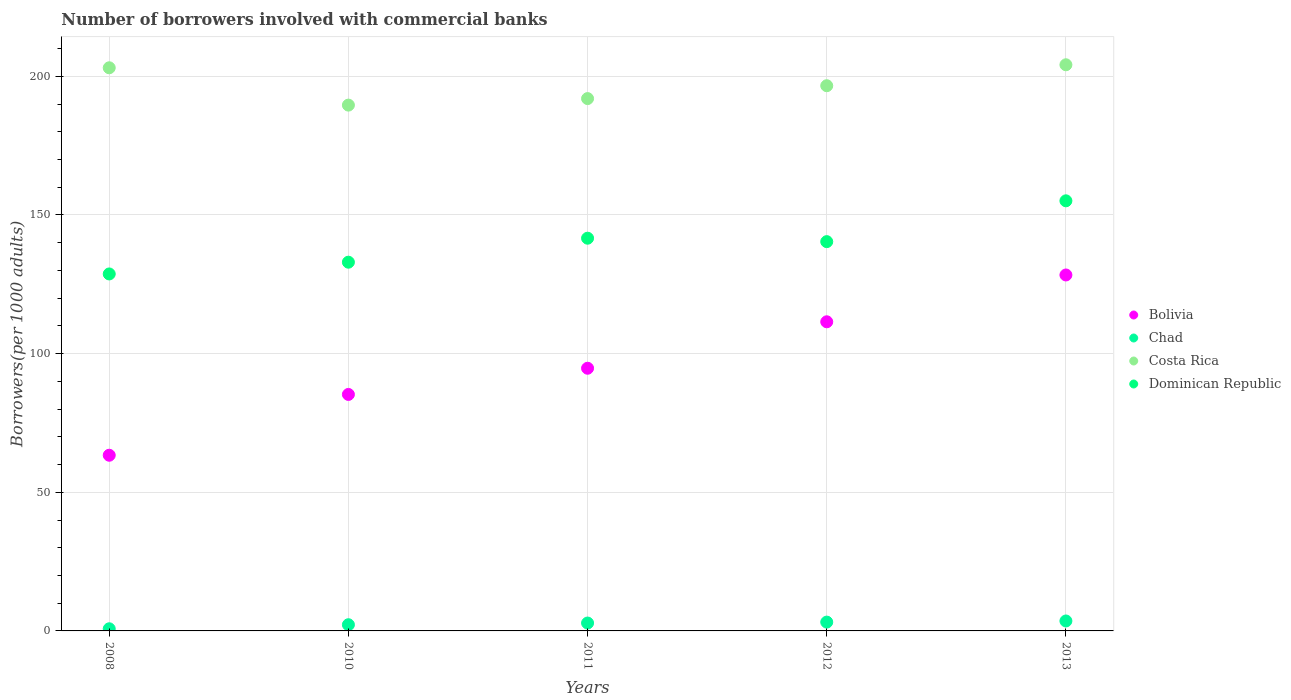How many different coloured dotlines are there?
Give a very brief answer. 4. What is the number of borrowers involved with commercial banks in Bolivia in 2012?
Your answer should be compact. 111.49. Across all years, what is the maximum number of borrowers involved with commercial banks in Chad?
Ensure brevity in your answer.  3.59. Across all years, what is the minimum number of borrowers involved with commercial banks in Costa Rica?
Offer a very short reply. 189.63. In which year was the number of borrowers involved with commercial banks in Bolivia maximum?
Provide a short and direct response. 2013. In which year was the number of borrowers involved with commercial banks in Bolivia minimum?
Your answer should be very brief. 2008. What is the total number of borrowers involved with commercial banks in Chad in the graph?
Provide a short and direct response. 12.62. What is the difference between the number of borrowers involved with commercial banks in Bolivia in 2010 and that in 2012?
Provide a short and direct response. -26.2. What is the difference between the number of borrowers involved with commercial banks in Costa Rica in 2013 and the number of borrowers involved with commercial banks in Chad in 2012?
Keep it short and to the point. 201. What is the average number of borrowers involved with commercial banks in Bolivia per year?
Make the answer very short. 96.65. In the year 2008, what is the difference between the number of borrowers involved with commercial banks in Bolivia and number of borrowers involved with commercial banks in Costa Rica?
Offer a very short reply. -139.73. What is the ratio of the number of borrowers involved with commercial banks in Dominican Republic in 2010 to that in 2011?
Your answer should be very brief. 0.94. Is the difference between the number of borrowers involved with commercial banks in Bolivia in 2008 and 2012 greater than the difference between the number of borrowers involved with commercial banks in Costa Rica in 2008 and 2012?
Provide a succinct answer. No. What is the difference between the highest and the second highest number of borrowers involved with commercial banks in Dominican Republic?
Make the answer very short. 13.49. What is the difference between the highest and the lowest number of borrowers involved with commercial banks in Chad?
Offer a very short reply. 2.82. Is it the case that in every year, the sum of the number of borrowers involved with commercial banks in Costa Rica and number of borrowers involved with commercial banks in Dominican Republic  is greater than the number of borrowers involved with commercial banks in Bolivia?
Provide a succinct answer. Yes. Does the number of borrowers involved with commercial banks in Costa Rica monotonically increase over the years?
Provide a short and direct response. No. Is the number of borrowers involved with commercial banks in Chad strictly less than the number of borrowers involved with commercial banks in Costa Rica over the years?
Provide a short and direct response. Yes. How many years are there in the graph?
Provide a succinct answer. 5. What is the difference between two consecutive major ticks on the Y-axis?
Your answer should be compact. 50. Are the values on the major ticks of Y-axis written in scientific E-notation?
Your response must be concise. No. Where does the legend appear in the graph?
Your response must be concise. Center right. How are the legend labels stacked?
Your answer should be compact. Vertical. What is the title of the graph?
Your answer should be compact. Number of borrowers involved with commercial banks. Does "Gabon" appear as one of the legend labels in the graph?
Ensure brevity in your answer.  No. What is the label or title of the X-axis?
Ensure brevity in your answer.  Years. What is the label or title of the Y-axis?
Offer a very short reply. Borrowers(per 1000 adults). What is the Borrowers(per 1000 adults) of Bolivia in 2008?
Provide a succinct answer. 63.36. What is the Borrowers(per 1000 adults) of Chad in 2008?
Your answer should be very brief. 0.77. What is the Borrowers(per 1000 adults) of Costa Rica in 2008?
Provide a short and direct response. 203.09. What is the Borrowers(per 1000 adults) in Dominican Republic in 2008?
Keep it short and to the point. 128.74. What is the Borrowers(per 1000 adults) in Bolivia in 2010?
Keep it short and to the point. 85.29. What is the Borrowers(per 1000 adults) of Chad in 2010?
Make the answer very short. 2.24. What is the Borrowers(per 1000 adults) of Costa Rica in 2010?
Your response must be concise. 189.63. What is the Borrowers(per 1000 adults) in Dominican Republic in 2010?
Your answer should be compact. 132.98. What is the Borrowers(per 1000 adults) of Bolivia in 2011?
Your response must be concise. 94.73. What is the Borrowers(per 1000 adults) of Chad in 2011?
Your answer should be compact. 2.84. What is the Borrowers(per 1000 adults) in Costa Rica in 2011?
Your answer should be very brief. 191.98. What is the Borrowers(per 1000 adults) in Dominican Republic in 2011?
Keep it short and to the point. 141.63. What is the Borrowers(per 1000 adults) of Bolivia in 2012?
Make the answer very short. 111.49. What is the Borrowers(per 1000 adults) of Chad in 2012?
Keep it short and to the point. 3.18. What is the Borrowers(per 1000 adults) in Costa Rica in 2012?
Ensure brevity in your answer.  196.62. What is the Borrowers(per 1000 adults) in Dominican Republic in 2012?
Provide a short and direct response. 140.39. What is the Borrowers(per 1000 adults) of Bolivia in 2013?
Your answer should be compact. 128.37. What is the Borrowers(per 1000 adults) in Chad in 2013?
Give a very brief answer. 3.59. What is the Borrowers(per 1000 adults) in Costa Rica in 2013?
Make the answer very short. 204.18. What is the Borrowers(per 1000 adults) in Dominican Republic in 2013?
Your answer should be very brief. 155.11. Across all years, what is the maximum Borrowers(per 1000 adults) in Bolivia?
Make the answer very short. 128.37. Across all years, what is the maximum Borrowers(per 1000 adults) in Chad?
Make the answer very short. 3.59. Across all years, what is the maximum Borrowers(per 1000 adults) of Costa Rica?
Ensure brevity in your answer.  204.18. Across all years, what is the maximum Borrowers(per 1000 adults) of Dominican Republic?
Make the answer very short. 155.11. Across all years, what is the minimum Borrowers(per 1000 adults) of Bolivia?
Give a very brief answer. 63.36. Across all years, what is the minimum Borrowers(per 1000 adults) of Chad?
Provide a succinct answer. 0.77. Across all years, what is the minimum Borrowers(per 1000 adults) in Costa Rica?
Make the answer very short. 189.63. Across all years, what is the minimum Borrowers(per 1000 adults) in Dominican Republic?
Your answer should be very brief. 128.74. What is the total Borrowers(per 1000 adults) in Bolivia in the graph?
Provide a short and direct response. 483.23. What is the total Borrowers(per 1000 adults) in Chad in the graph?
Offer a terse response. 12.62. What is the total Borrowers(per 1000 adults) in Costa Rica in the graph?
Offer a very short reply. 985.5. What is the total Borrowers(per 1000 adults) in Dominican Republic in the graph?
Provide a short and direct response. 698.85. What is the difference between the Borrowers(per 1000 adults) of Bolivia in 2008 and that in 2010?
Make the answer very short. -21.93. What is the difference between the Borrowers(per 1000 adults) of Chad in 2008 and that in 2010?
Keep it short and to the point. -1.46. What is the difference between the Borrowers(per 1000 adults) of Costa Rica in 2008 and that in 2010?
Make the answer very short. 13.46. What is the difference between the Borrowers(per 1000 adults) in Dominican Republic in 2008 and that in 2010?
Provide a succinct answer. -4.24. What is the difference between the Borrowers(per 1000 adults) in Bolivia in 2008 and that in 2011?
Make the answer very short. -31.37. What is the difference between the Borrowers(per 1000 adults) in Chad in 2008 and that in 2011?
Provide a succinct answer. -2.07. What is the difference between the Borrowers(per 1000 adults) in Costa Rica in 2008 and that in 2011?
Give a very brief answer. 11.11. What is the difference between the Borrowers(per 1000 adults) of Dominican Republic in 2008 and that in 2011?
Provide a short and direct response. -12.89. What is the difference between the Borrowers(per 1000 adults) in Bolivia in 2008 and that in 2012?
Your response must be concise. -48.13. What is the difference between the Borrowers(per 1000 adults) of Chad in 2008 and that in 2012?
Your response must be concise. -2.41. What is the difference between the Borrowers(per 1000 adults) of Costa Rica in 2008 and that in 2012?
Offer a terse response. 6.47. What is the difference between the Borrowers(per 1000 adults) of Dominican Republic in 2008 and that in 2012?
Offer a terse response. -11.65. What is the difference between the Borrowers(per 1000 adults) in Bolivia in 2008 and that in 2013?
Your answer should be compact. -65.01. What is the difference between the Borrowers(per 1000 adults) of Chad in 2008 and that in 2013?
Provide a short and direct response. -2.82. What is the difference between the Borrowers(per 1000 adults) of Costa Rica in 2008 and that in 2013?
Your answer should be very brief. -1.09. What is the difference between the Borrowers(per 1000 adults) of Dominican Republic in 2008 and that in 2013?
Provide a succinct answer. -26.37. What is the difference between the Borrowers(per 1000 adults) in Bolivia in 2010 and that in 2011?
Make the answer very short. -9.45. What is the difference between the Borrowers(per 1000 adults) of Chad in 2010 and that in 2011?
Your response must be concise. -0.61. What is the difference between the Borrowers(per 1000 adults) in Costa Rica in 2010 and that in 2011?
Give a very brief answer. -2.35. What is the difference between the Borrowers(per 1000 adults) in Dominican Republic in 2010 and that in 2011?
Ensure brevity in your answer.  -8.65. What is the difference between the Borrowers(per 1000 adults) of Bolivia in 2010 and that in 2012?
Provide a succinct answer. -26.2. What is the difference between the Borrowers(per 1000 adults) in Chad in 2010 and that in 2012?
Offer a terse response. -0.94. What is the difference between the Borrowers(per 1000 adults) in Costa Rica in 2010 and that in 2012?
Your answer should be compact. -6.99. What is the difference between the Borrowers(per 1000 adults) of Dominican Republic in 2010 and that in 2012?
Provide a short and direct response. -7.41. What is the difference between the Borrowers(per 1000 adults) in Bolivia in 2010 and that in 2013?
Your answer should be compact. -43.08. What is the difference between the Borrowers(per 1000 adults) in Chad in 2010 and that in 2013?
Ensure brevity in your answer.  -1.35. What is the difference between the Borrowers(per 1000 adults) in Costa Rica in 2010 and that in 2013?
Your answer should be compact. -14.55. What is the difference between the Borrowers(per 1000 adults) in Dominican Republic in 2010 and that in 2013?
Offer a terse response. -22.14. What is the difference between the Borrowers(per 1000 adults) in Bolivia in 2011 and that in 2012?
Provide a succinct answer. -16.75. What is the difference between the Borrowers(per 1000 adults) in Chad in 2011 and that in 2012?
Make the answer very short. -0.34. What is the difference between the Borrowers(per 1000 adults) in Costa Rica in 2011 and that in 2012?
Give a very brief answer. -4.64. What is the difference between the Borrowers(per 1000 adults) of Dominican Republic in 2011 and that in 2012?
Ensure brevity in your answer.  1.24. What is the difference between the Borrowers(per 1000 adults) of Bolivia in 2011 and that in 2013?
Offer a terse response. -33.64. What is the difference between the Borrowers(per 1000 adults) in Chad in 2011 and that in 2013?
Provide a short and direct response. -0.75. What is the difference between the Borrowers(per 1000 adults) in Costa Rica in 2011 and that in 2013?
Keep it short and to the point. -12.19. What is the difference between the Borrowers(per 1000 adults) in Dominican Republic in 2011 and that in 2013?
Your answer should be very brief. -13.49. What is the difference between the Borrowers(per 1000 adults) of Bolivia in 2012 and that in 2013?
Your response must be concise. -16.88. What is the difference between the Borrowers(per 1000 adults) in Chad in 2012 and that in 2013?
Your response must be concise. -0.41. What is the difference between the Borrowers(per 1000 adults) of Costa Rica in 2012 and that in 2013?
Make the answer very short. -7.55. What is the difference between the Borrowers(per 1000 adults) in Dominican Republic in 2012 and that in 2013?
Ensure brevity in your answer.  -14.72. What is the difference between the Borrowers(per 1000 adults) in Bolivia in 2008 and the Borrowers(per 1000 adults) in Chad in 2010?
Provide a succinct answer. 61.12. What is the difference between the Borrowers(per 1000 adults) in Bolivia in 2008 and the Borrowers(per 1000 adults) in Costa Rica in 2010?
Your answer should be very brief. -126.27. What is the difference between the Borrowers(per 1000 adults) in Bolivia in 2008 and the Borrowers(per 1000 adults) in Dominican Republic in 2010?
Your response must be concise. -69.62. What is the difference between the Borrowers(per 1000 adults) of Chad in 2008 and the Borrowers(per 1000 adults) of Costa Rica in 2010?
Ensure brevity in your answer.  -188.86. What is the difference between the Borrowers(per 1000 adults) of Chad in 2008 and the Borrowers(per 1000 adults) of Dominican Republic in 2010?
Offer a very short reply. -132.21. What is the difference between the Borrowers(per 1000 adults) in Costa Rica in 2008 and the Borrowers(per 1000 adults) in Dominican Republic in 2010?
Give a very brief answer. 70.11. What is the difference between the Borrowers(per 1000 adults) in Bolivia in 2008 and the Borrowers(per 1000 adults) in Chad in 2011?
Your response must be concise. 60.51. What is the difference between the Borrowers(per 1000 adults) in Bolivia in 2008 and the Borrowers(per 1000 adults) in Costa Rica in 2011?
Make the answer very short. -128.62. What is the difference between the Borrowers(per 1000 adults) of Bolivia in 2008 and the Borrowers(per 1000 adults) of Dominican Republic in 2011?
Keep it short and to the point. -78.27. What is the difference between the Borrowers(per 1000 adults) of Chad in 2008 and the Borrowers(per 1000 adults) of Costa Rica in 2011?
Offer a very short reply. -191.21. What is the difference between the Borrowers(per 1000 adults) of Chad in 2008 and the Borrowers(per 1000 adults) of Dominican Republic in 2011?
Your answer should be compact. -140.86. What is the difference between the Borrowers(per 1000 adults) in Costa Rica in 2008 and the Borrowers(per 1000 adults) in Dominican Republic in 2011?
Provide a succinct answer. 61.46. What is the difference between the Borrowers(per 1000 adults) of Bolivia in 2008 and the Borrowers(per 1000 adults) of Chad in 2012?
Offer a terse response. 60.18. What is the difference between the Borrowers(per 1000 adults) of Bolivia in 2008 and the Borrowers(per 1000 adults) of Costa Rica in 2012?
Provide a short and direct response. -133.27. What is the difference between the Borrowers(per 1000 adults) of Bolivia in 2008 and the Borrowers(per 1000 adults) of Dominican Republic in 2012?
Give a very brief answer. -77.03. What is the difference between the Borrowers(per 1000 adults) in Chad in 2008 and the Borrowers(per 1000 adults) in Costa Rica in 2012?
Your answer should be very brief. -195.85. What is the difference between the Borrowers(per 1000 adults) of Chad in 2008 and the Borrowers(per 1000 adults) of Dominican Republic in 2012?
Your answer should be compact. -139.62. What is the difference between the Borrowers(per 1000 adults) in Costa Rica in 2008 and the Borrowers(per 1000 adults) in Dominican Republic in 2012?
Make the answer very short. 62.7. What is the difference between the Borrowers(per 1000 adults) in Bolivia in 2008 and the Borrowers(per 1000 adults) in Chad in 2013?
Provide a succinct answer. 59.77. What is the difference between the Borrowers(per 1000 adults) in Bolivia in 2008 and the Borrowers(per 1000 adults) in Costa Rica in 2013?
Keep it short and to the point. -140.82. What is the difference between the Borrowers(per 1000 adults) of Bolivia in 2008 and the Borrowers(per 1000 adults) of Dominican Republic in 2013?
Offer a very short reply. -91.76. What is the difference between the Borrowers(per 1000 adults) of Chad in 2008 and the Borrowers(per 1000 adults) of Costa Rica in 2013?
Your answer should be very brief. -203.4. What is the difference between the Borrowers(per 1000 adults) of Chad in 2008 and the Borrowers(per 1000 adults) of Dominican Republic in 2013?
Offer a terse response. -154.34. What is the difference between the Borrowers(per 1000 adults) of Costa Rica in 2008 and the Borrowers(per 1000 adults) of Dominican Republic in 2013?
Provide a succinct answer. 47.98. What is the difference between the Borrowers(per 1000 adults) of Bolivia in 2010 and the Borrowers(per 1000 adults) of Chad in 2011?
Keep it short and to the point. 82.44. What is the difference between the Borrowers(per 1000 adults) in Bolivia in 2010 and the Borrowers(per 1000 adults) in Costa Rica in 2011?
Provide a short and direct response. -106.7. What is the difference between the Borrowers(per 1000 adults) in Bolivia in 2010 and the Borrowers(per 1000 adults) in Dominican Republic in 2011?
Give a very brief answer. -56.34. What is the difference between the Borrowers(per 1000 adults) in Chad in 2010 and the Borrowers(per 1000 adults) in Costa Rica in 2011?
Offer a terse response. -189.75. What is the difference between the Borrowers(per 1000 adults) of Chad in 2010 and the Borrowers(per 1000 adults) of Dominican Republic in 2011?
Keep it short and to the point. -139.39. What is the difference between the Borrowers(per 1000 adults) of Costa Rica in 2010 and the Borrowers(per 1000 adults) of Dominican Republic in 2011?
Your response must be concise. 48. What is the difference between the Borrowers(per 1000 adults) of Bolivia in 2010 and the Borrowers(per 1000 adults) of Chad in 2012?
Offer a terse response. 82.11. What is the difference between the Borrowers(per 1000 adults) of Bolivia in 2010 and the Borrowers(per 1000 adults) of Costa Rica in 2012?
Provide a short and direct response. -111.34. What is the difference between the Borrowers(per 1000 adults) of Bolivia in 2010 and the Borrowers(per 1000 adults) of Dominican Republic in 2012?
Keep it short and to the point. -55.1. What is the difference between the Borrowers(per 1000 adults) of Chad in 2010 and the Borrowers(per 1000 adults) of Costa Rica in 2012?
Your response must be concise. -194.39. What is the difference between the Borrowers(per 1000 adults) in Chad in 2010 and the Borrowers(per 1000 adults) in Dominican Republic in 2012?
Your response must be concise. -138.15. What is the difference between the Borrowers(per 1000 adults) of Costa Rica in 2010 and the Borrowers(per 1000 adults) of Dominican Republic in 2012?
Keep it short and to the point. 49.24. What is the difference between the Borrowers(per 1000 adults) of Bolivia in 2010 and the Borrowers(per 1000 adults) of Chad in 2013?
Offer a terse response. 81.7. What is the difference between the Borrowers(per 1000 adults) in Bolivia in 2010 and the Borrowers(per 1000 adults) in Costa Rica in 2013?
Keep it short and to the point. -118.89. What is the difference between the Borrowers(per 1000 adults) of Bolivia in 2010 and the Borrowers(per 1000 adults) of Dominican Republic in 2013?
Provide a succinct answer. -69.83. What is the difference between the Borrowers(per 1000 adults) in Chad in 2010 and the Borrowers(per 1000 adults) in Costa Rica in 2013?
Ensure brevity in your answer.  -201.94. What is the difference between the Borrowers(per 1000 adults) of Chad in 2010 and the Borrowers(per 1000 adults) of Dominican Republic in 2013?
Provide a short and direct response. -152.88. What is the difference between the Borrowers(per 1000 adults) of Costa Rica in 2010 and the Borrowers(per 1000 adults) of Dominican Republic in 2013?
Give a very brief answer. 34.51. What is the difference between the Borrowers(per 1000 adults) in Bolivia in 2011 and the Borrowers(per 1000 adults) in Chad in 2012?
Keep it short and to the point. 91.55. What is the difference between the Borrowers(per 1000 adults) in Bolivia in 2011 and the Borrowers(per 1000 adults) in Costa Rica in 2012?
Keep it short and to the point. -101.89. What is the difference between the Borrowers(per 1000 adults) of Bolivia in 2011 and the Borrowers(per 1000 adults) of Dominican Republic in 2012?
Keep it short and to the point. -45.66. What is the difference between the Borrowers(per 1000 adults) of Chad in 2011 and the Borrowers(per 1000 adults) of Costa Rica in 2012?
Offer a very short reply. -193.78. What is the difference between the Borrowers(per 1000 adults) of Chad in 2011 and the Borrowers(per 1000 adults) of Dominican Republic in 2012?
Provide a short and direct response. -137.55. What is the difference between the Borrowers(per 1000 adults) in Costa Rica in 2011 and the Borrowers(per 1000 adults) in Dominican Republic in 2012?
Make the answer very short. 51.59. What is the difference between the Borrowers(per 1000 adults) in Bolivia in 2011 and the Borrowers(per 1000 adults) in Chad in 2013?
Offer a very short reply. 91.14. What is the difference between the Borrowers(per 1000 adults) of Bolivia in 2011 and the Borrowers(per 1000 adults) of Costa Rica in 2013?
Your answer should be compact. -109.44. What is the difference between the Borrowers(per 1000 adults) of Bolivia in 2011 and the Borrowers(per 1000 adults) of Dominican Republic in 2013?
Make the answer very short. -60.38. What is the difference between the Borrowers(per 1000 adults) of Chad in 2011 and the Borrowers(per 1000 adults) of Costa Rica in 2013?
Your answer should be compact. -201.33. What is the difference between the Borrowers(per 1000 adults) in Chad in 2011 and the Borrowers(per 1000 adults) in Dominican Republic in 2013?
Offer a very short reply. -152.27. What is the difference between the Borrowers(per 1000 adults) of Costa Rica in 2011 and the Borrowers(per 1000 adults) of Dominican Republic in 2013?
Your response must be concise. 36.87. What is the difference between the Borrowers(per 1000 adults) in Bolivia in 2012 and the Borrowers(per 1000 adults) in Chad in 2013?
Give a very brief answer. 107.9. What is the difference between the Borrowers(per 1000 adults) of Bolivia in 2012 and the Borrowers(per 1000 adults) of Costa Rica in 2013?
Provide a succinct answer. -92.69. What is the difference between the Borrowers(per 1000 adults) in Bolivia in 2012 and the Borrowers(per 1000 adults) in Dominican Republic in 2013?
Provide a short and direct response. -43.63. What is the difference between the Borrowers(per 1000 adults) in Chad in 2012 and the Borrowers(per 1000 adults) in Costa Rica in 2013?
Give a very brief answer. -201. What is the difference between the Borrowers(per 1000 adults) in Chad in 2012 and the Borrowers(per 1000 adults) in Dominican Republic in 2013?
Provide a succinct answer. -151.94. What is the difference between the Borrowers(per 1000 adults) in Costa Rica in 2012 and the Borrowers(per 1000 adults) in Dominican Republic in 2013?
Keep it short and to the point. 41.51. What is the average Borrowers(per 1000 adults) in Bolivia per year?
Make the answer very short. 96.65. What is the average Borrowers(per 1000 adults) in Chad per year?
Offer a very short reply. 2.52. What is the average Borrowers(per 1000 adults) in Costa Rica per year?
Provide a short and direct response. 197.1. What is the average Borrowers(per 1000 adults) in Dominican Republic per year?
Keep it short and to the point. 139.77. In the year 2008, what is the difference between the Borrowers(per 1000 adults) in Bolivia and Borrowers(per 1000 adults) in Chad?
Keep it short and to the point. 62.59. In the year 2008, what is the difference between the Borrowers(per 1000 adults) in Bolivia and Borrowers(per 1000 adults) in Costa Rica?
Provide a succinct answer. -139.73. In the year 2008, what is the difference between the Borrowers(per 1000 adults) of Bolivia and Borrowers(per 1000 adults) of Dominican Republic?
Your answer should be compact. -65.38. In the year 2008, what is the difference between the Borrowers(per 1000 adults) of Chad and Borrowers(per 1000 adults) of Costa Rica?
Make the answer very short. -202.32. In the year 2008, what is the difference between the Borrowers(per 1000 adults) of Chad and Borrowers(per 1000 adults) of Dominican Republic?
Your response must be concise. -127.97. In the year 2008, what is the difference between the Borrowers(per 1000 adults) of Costa Rica and Borrowers(per 1000 adults) of Dominican Republic?
Provide a succinct answer. 74.35. In the year 2010, what is the difference between the Borrowers(per 1000 adults) of Bolivia and Borrowers(per 1000 adults) of Chad?
Offer a very short reply. 83.05. In the year 2010, what is the difference between the Borrowers(per 1000 adults) in Bolivia and Borrowers(per 1000 adults) in Costa Rica?
Offer a very short reply. -104.34. In the year 2010, what is the difference between the Borrowers(per 1000 adults) of Bolivia and Borrowers(per 1000 adults) of Dominican Republic?
Your response must be concise. -47.69. In the year 2010, what is the difference between the Borrowers(per 1000 adults) of Chad and Borrowers(per 1000 adults) of Costa Rica?
Your response must be concise. -187.39. In the year 2010, what is the difference between the Borrowers(per 1000 adults) in Chad and Borrowers(per 1000 adults) in Dominican Republic?
Offer a terse response. -130.74. In the year 2010, what is the difference between the Borrowers(per 1000 adults) in Costa Rica and Borrowers(per 1000 adults) in Dominican Republic?
Your answer should be compact. 56.65. In the year 2011, what is the difference between the Borrowers(per 1000 adults) in Bolivia and Borrowers(per 1000 adults) in Chad?
Your answer should be very brief. 91.89. In the year 2011, what is the difference between the Borrowers(per 1000 adults) in Bolivia and Borrowers(per 1000 adults) in Costa Rica?
Ensure brevity in your answer.  -97.25. In the year 2011, what is the difference between the Borrowers(per 1000 adults) in Bolivia and Borrowers(per 1000 adults) in Dominican Republic?
Your answer should be very brief. -46.9. In the year 2011, what is the difference between the Borrowers(per 1000 adults) in Chad and Borrowers(per 1000 adults) in Costa Rica?
Provide a short and direct response. -189.14. In the year 2011, what is the difference between the Borrowers(per 1000 adults) of Chad and Borrowers(per 1000 adults) of Dominican Republic?
Your response must be concise. -138.79. In the year 2011, what is the difference between the Borrowers(per 1000 adults) of Costa Rica and Borrowers(per 1000 adults) of Dominican Republic?
Your answer should be compact. 50.35. In the year 2012, what is the difference between the Borrowers(per 1000 adults) of Bolivia and Borrowers(per 1000 adults) of Chad?
Make the answer very short. 108.31. In the year 2012, what is the difference between the Borrowers(per 1000 adults) in Bolivia and Borrowers(per 1000 adults) in Costa Rica?
Provide a short and direct response. -85.14. In the year 2012, what is the difference between the Borrowers(per 1000 adults) of Bolivia and Borrowers(per 1000 adults) of Dominican Republic?
Your answer should be compact. -28.9. In the year 2012, what is the difference between the Borrowers(per 1000 adults) in Chad and Borrowers(per 1000 adults) in Costa Rica?
Offer a very short reply. -193.44. In the year 2012, what is the difference between the Borrowers(per 1000 adults) of Chad and Borrowers(per 1000 adults) of Dominican Republic?
Provide a succinct answer. -137.21. In the year 2012, what is the difference between the Borrowers(per 1000 adults) of Costa Rica and Borrowers(per 1000 adults) of Dominican Republic?
Provide a short and direct response. 56.23. In the year 2013, what is the difference between the Borrowers(per 1000 adults) of Bolivia and Borrowers(per 1000 adults) of Chad?
Provide a short and direct response. 124.78. In the year 2013, what is the difference between the Borrowers(per 1000 adults) in Bolivia and Borrowers(per 1000 adults) in Costa Rica?
Your response must be concise. -75.8. In the year 2013, what is the difference between the Borrowers(per 1000 adults) in Bolivia and Borrowers(per 1000 adults) in Dominican Republic?
Your answer should be compact. -26.74. In the year 2013, what is the difference between the Borrowers(per 1000 adults) in Chad and Borrowers(per 1000 adults) in Costa Rica?
Keep it short and to the point. -200.59. In the year 2013, what is the difference between the Borrowers(per 1000 adults) in Chad and Borrowers(per 1000 adults) in Dominican Republic?
Give a very brief answer. -151.53. In the year 2013, what is the difference between the Borrowers(per 1000 adults) in Costa Rica and Borrowers(per 1000 adults) in Dominican Republic?
Your answer should be compact. 49.06. What is the ratio of the Borrowers(per 1000 adults) of Bolivia in 2008 to that in 2010?
Offer a very short reply. 0.74. What is the ratio of the Borrowers(per 1000 adults) in Chad in 2008 to that in 2010?
Ensure brevity in your answer.  0.35. What is the ratio of the Borrowers(per 1000 adults) in Costa Rica in 2008 to that in 2010?
Provide a short and direct response. 1.07. What is the ratio of the Borrowers(per 1000 adults) in Dominican Republic in 2008 to that in 2010?
Give a very brief answer. 0.97. What is the ratio of the Borrowers(per 1000 adults) in Bolivia in 2008 to that in 2011?
Give a very brief answer. 0.67. What is the ratio of the Borrowers(per 1000 adults) in Chad in 2008 to that in 2011?
Your response must be concise. 0.27. What is the ratio of the Borrowers(per 1000 adults) in Costa Rica in 2008 to that in 2011?
Your answer should be compact. 1.06. What is the ratio of the Borrowers(per 1000 adults) of Dominican Republic in 2008 to that in 2011?
Your answer should be compact. 0.91. What is the ratio of the Borrowers(per 1000 adults) of Bolivia in 2008 to that in 2012?
Make the answer very short. 0.57. What is the ratio of the Borrowers(per 1000 adults) in Chad in 2008 to that in 2012?
Offer a terse response. 0.24. What is the ratio of the Borrowers(per 1000 adults) of Costa Rica in 2008 to that in 2012?
Your answer should be compact. 1.03. What is the ratio of the Borrowers(per 1000 adults) of Dominican Republic in 2008 to that in 2012?
Offer a terse response. 0.92. What is the ratio of the Borrowers(per 1000 adults) in Bolivia in 2008 to that in 2013?
Provide a short and direct response. 0.49. What is the ratio of the Borrowers(per 1000 adults) of Chad in 2008 to that in 2013?
Your response must be concise. 0.22. What is the ratio of the Borrowers(per 1000 adults) of Dominican Republic in 2008 to that in 2013?
Make the answer very short. 0.83. What is the ratio of the Borrowers(per 1000 adults) of Bolivia in 2010 to that in 2011?
Your answer should be very brief. 0.9. What is the ratio of the Borrowers(per 1000 adults) of Chad in 2010 to that in 2011?
Keep it short and to the point. 0.79. What is the ratio of the Borrowers(per 1000 adults) of Costa Rica in 2010 to that in 2011?
Keep it short and to the point. 0.99. What is the ratio of the Borrowers(per 1000 adults) of Dominican Republic in 2010 to that in 2011?
Provide a short and direct response. 0.94. What is the ratio of the Borrowers(per 1000 adults) of Bolivia in 2010 to that in 2012?
Offer a terse response. 0.77. What is the ratio of the Borrowers(per 1000 adults) in Chad in 2010 to that in 2012?
Keep it short and to the point. 0.7. What is the ratio of the Borrowers(per 1000 adults) in Costa Rica in 2010 to that in 2012?
Make the answer very short. 0.96. What is the ratio of the Borrowers(per 1000 adults) of Dominican Republic in 2010 to that in 2012?
Provide a short and direct response. 0.95. What is the ratio of the Borrowers(per 1000 adults) of Bolivia in 2010 to that in 2013?
Keep it short and to the point. 0.66. What is the ratio of the Borrowers(per 1000 adults) of Chad in 2010 to that in 2013?
Your answer should be compact. 0.62. What is the ratio of the Borrowers(per 1000 adults) of Costa Rica in 2010 to that in 2013?
Offer a terse response. 0.93. What is the ratio of the Borrowers(per 1000 adults) in Dominican Republic in 2010 to that in 2013?
Your answer should be compact. 0.86. What is the ratio of the Borrowers(per 1000 adults) in Bolivia in 2011 to that in 2012?
Keep it short and to the point. 0.85. What is the ratio of the Borrowers(per 1000 adults) in Chad in 2011 to that in 2012?
Your answer should be very brief. 0.89. What is the ratio of the Borrowers(per 1000 adults) of Costa Rica in 2011 to that in 2012?
Give a very brief answer. 0.98. What is the ratio of the Borrowers(per 1000 adults) of Dominican Republic in 2011 to that in 2012?
Your answer should be very brief. 1.01. What is the ratio of the Borrowers(per 1000 adults) in Bolivia in 2011 to that in 2013?
Make the answer very short. 0.74. What is the ratio of the Borrowers(per 1000 adults) in Chad in 2011 to that in 2013?
Give a very brief answer. 0.79. What is the ratio of the Borrowers(per 1000 adults) in Costa Rica in 2011 to that in 2013?
Give a very brief answer. 0.94. What is the ratio of the Borrowers(per 1000 adults) in Dominican Republic in 2011 to that in 2013?
Your answer should be very brief. 0.91. What is the ratio of the Borrowers(per 1000 adults) of Bolivia in 2012 to that in 2013?
Make the answer very short. 0.87. What is the ratio of the Borrowers(per 1000 adults) in Chad in 2012 to that in 2013?
Make the answer very short. 0.89. What is the ratio of the Borrowers(per 1000 adults) in Costa Rica in 2012 to that in 2013?
Offer a very short reply. 0.96. What is the ratio of the Borrowers(per 1000 adults) in Dominican Republic in 2012 to that in 2013?
Keep it short and to the point. 0.91. What is the difference between the highest and the second highest Borrowers(per 1000 adults) in Bolivia?
Keep it short and to the point. 16.88. What is the difference between the highest and the second highest Borrowers(per 1000 adults) of Chad?
Ensure brevity in your answer.  0.41. What is the difference between the highest and the second highest Borrowers(per 1000 adults) in Costa Rica?
Your answer should be compact. 1.09. What is the difference between the highest and the second highest Borrowers(per 1000 adults) in Dominican Republic?
Ensure brevity in your answer.  13.49. What is the difference between the highest and the lowest Borrowers(per 1000 adults) of Bolivia?
Your answer should be very brief. 65.01. What is the difference between the highest and the lowest Borrowers(per 1000 adults) of Chad?
Your answer should be very brief. 2.82. What is the difference between the highest and the lowest Borrowers(per 1000 adults) of Costa Rica?
Your answer should be very brief. 14.55. What is the difference between the highest and the lowest Borrowers(per 1000 adults) in Dominican Republic?
Provide a succinct answer. 26.37. 